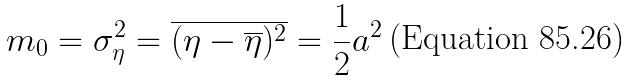<formula> <loc_0><loc_0><loc_500><loc_500>m _ { 0 } = \sigma _ { \eta } ^ { 2 } = \overline { ( \eta - \overline { \eta } ) ^ { 2 } } = \frac { 1 } { 2 } a ^ { 2 }</formula> 